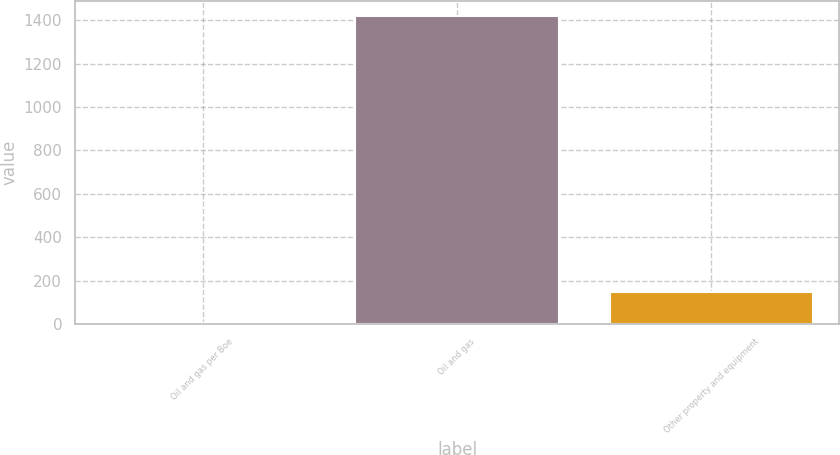Convert chart. <chart><loc_0><loc_0><loc_500><loc_500><bar_chart><fcel>Oil and gas per Boe<fcel>Oil and gas<fcel>Other property and equipment<nl><fcel>7.15<fcel>1419<fcel>148.34<nl></chart> 